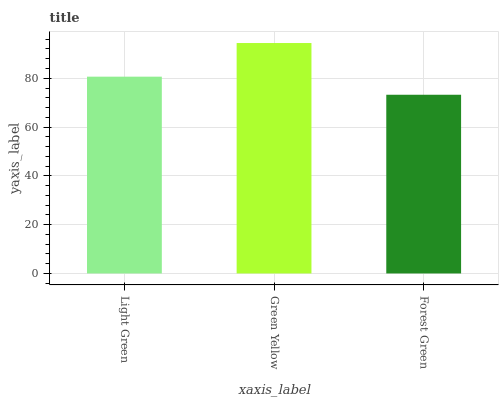Is Forest Green the minimum?
Answer yes or no. Yes. Is Green Yellow the maximum?
Answer yes or no. Yes. Is Green Yellow the minimum?
Answer yes or no. No. Is Forest Green the maximum?
Answer yes or no. No. Is Green Yellow greater than Forest Green?
Answer yes or no. Yes. Is Forest Green less than Green Yellow?
Answer yes or no. Yes. Is Forest Green greater than Green Yellow?
Answer yes or no. No. Is Green Yellow less than Forest Green?
Answer yes or no. No. Is Light Green the high median?
Answer yes or no. Yes. Is Light Green the low median?
Answer yes or no. Yes. Is Forest Green the high median?
Answer yes or no. No. Is Forest Green the low median?
Answer yes or no. No. 